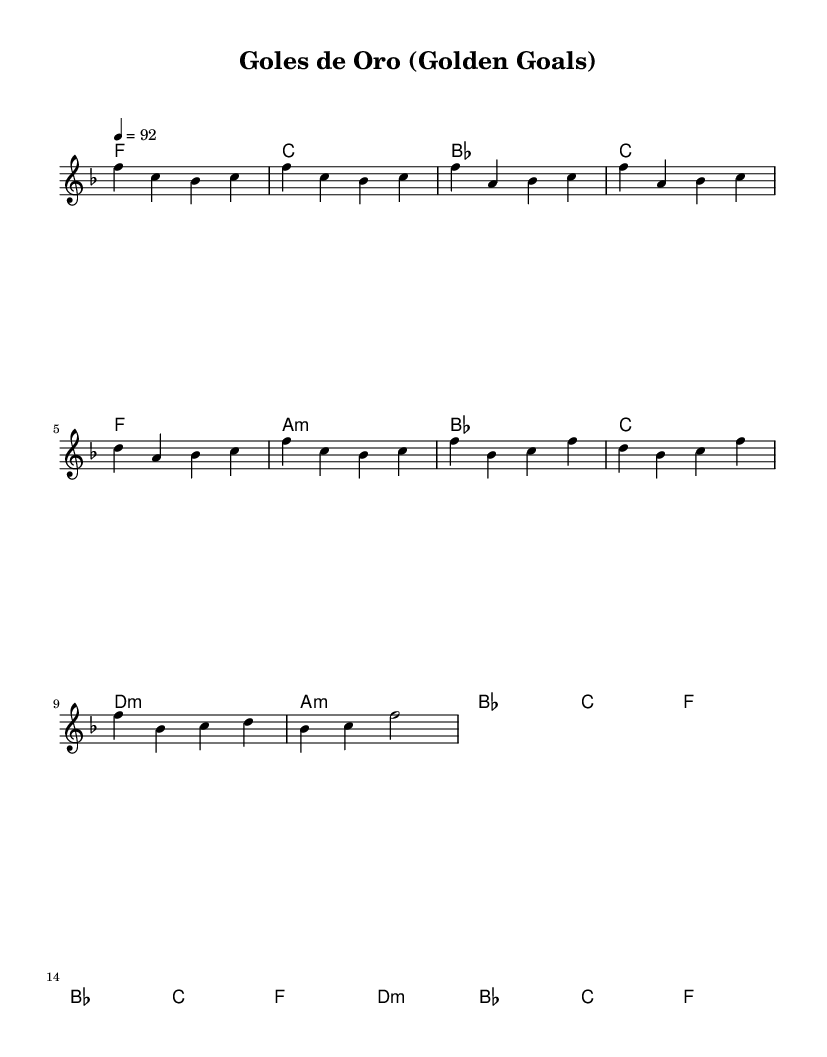What is the key signature of this music? The key signature labeled in the score indicates F major, which contains one flat (B flat).
Answer: F major What is the time signature of this music? The time signature is specified in the score as 4/4, indicating four beats per measure with each beat represented by a quarter note.
Answer: 4/4 What is the tempo marking of this music? The tempo marking shows a quarter note equals 92, indicating a moderate speed for the music.
Answer: 92 What is the name of the song? The title of the piece is displayed prominently at the beginning of the score as "Goles de Oro".
Answer: Goles de Oro How many measures are in the chorus section? To find the number of measures in the chorus, count the measures from the section labeled as "Chorus," which has four measures.
Answer: 4 What type of harmony is used in the verse? The harmonies for the verse section contain a mix of major and minor chords as shown by the chord names listed. Specific examples are F, A minor, and D minor.
Answer: Major and minor How does the chorus reflect typical disco characteristics? The chorus features repetitive phrases and upbeat rhythms typical of disco songs, with memorable lyrics celebrating a soccer hero, enhancing its nostalgic vibe.
Answer: Repetitive phrases 